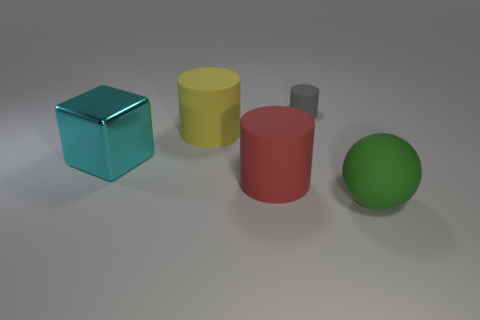Add 3 small cyan matte balls. How many objects exist? 8 Subtract all cubes. How many objects are left? 4 Subtract all large green metal objects. Subtract all green balls. How many objects are left? 4 Add 3 gray objects. How many gray objects are left? 4 Add 5 small cyan matte cylinders. How many small cyan matte cylinders exist? 5 Subtract all red cylinders. How many cylinders are left? 2 Subtract all large cylinders. How many cylinders are left? 1 Subtract 0 yellow blocks. How many objects are left? 5 Subtract 2 cylinders. How many cylinders are left? 1 Subtract all yellow cylinders. Subtract all cyan cubes. How many cylinders are left? 2 